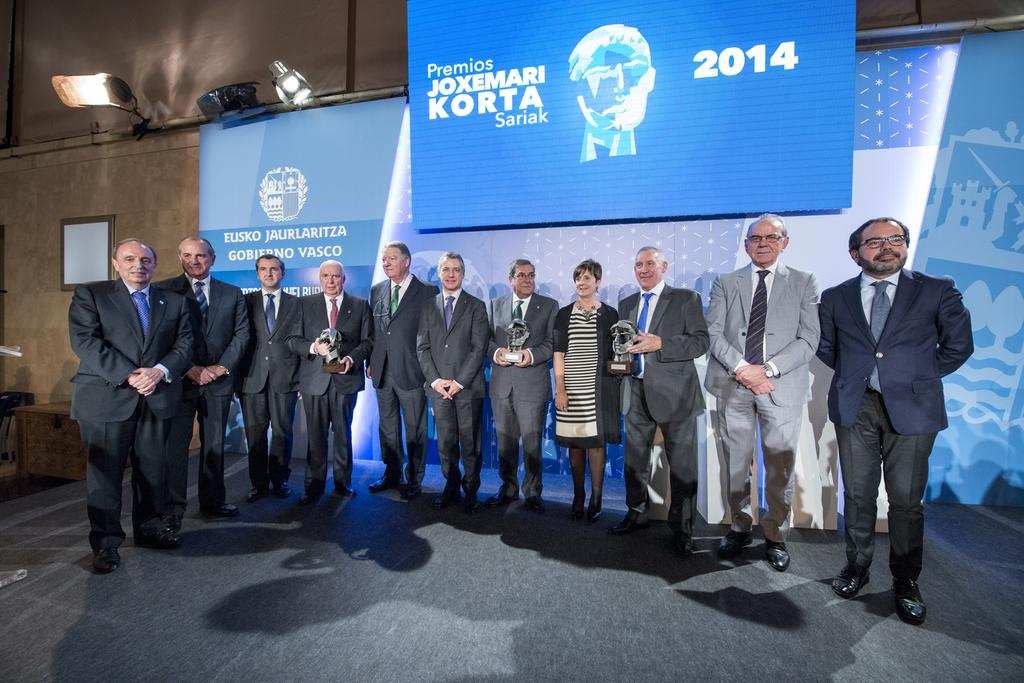How many people are in the image? There is a group of persons in the image. What are the persons wearing? The persons are wearing suits. What are some of the persons holding? Some of the persons are holding awards. What can be seen in the background of the image? There is a blue color sheet, lights, and a wall in the background of the image. What is the creator's opinion about the parent's decision in the image? There is no creator or parent present in the image, and therefore no such opinions can be observed. 